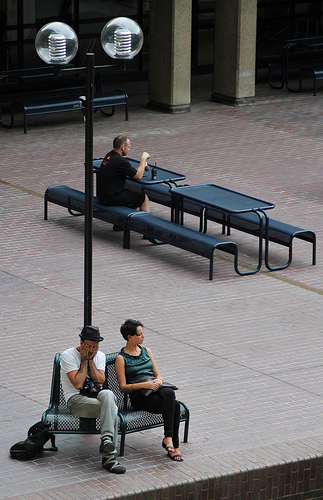Could you discuss the overall mood or atmosphere this scene portrays? This scene exudes a serene and somewhat introspective atmosphere, typical of a quiet public square. The spacing between individuals and their engagement in solitary activities enhances a sense of peaceful coexistence within a communal space. 